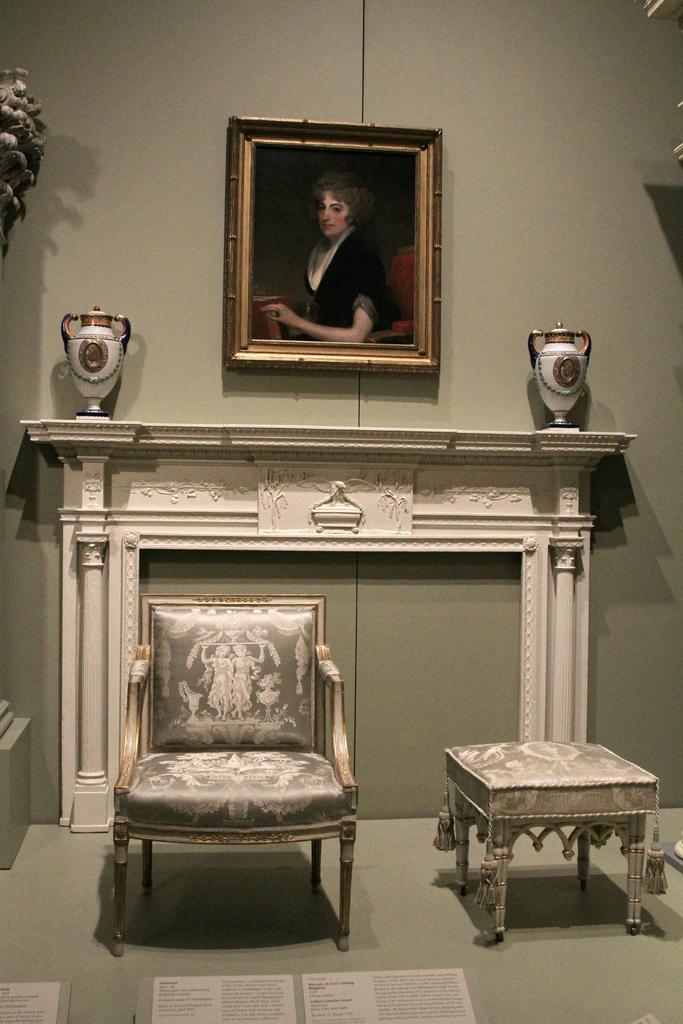Can you describe this image briefly? In this room there is a chair,stool and a frame on the wall. 